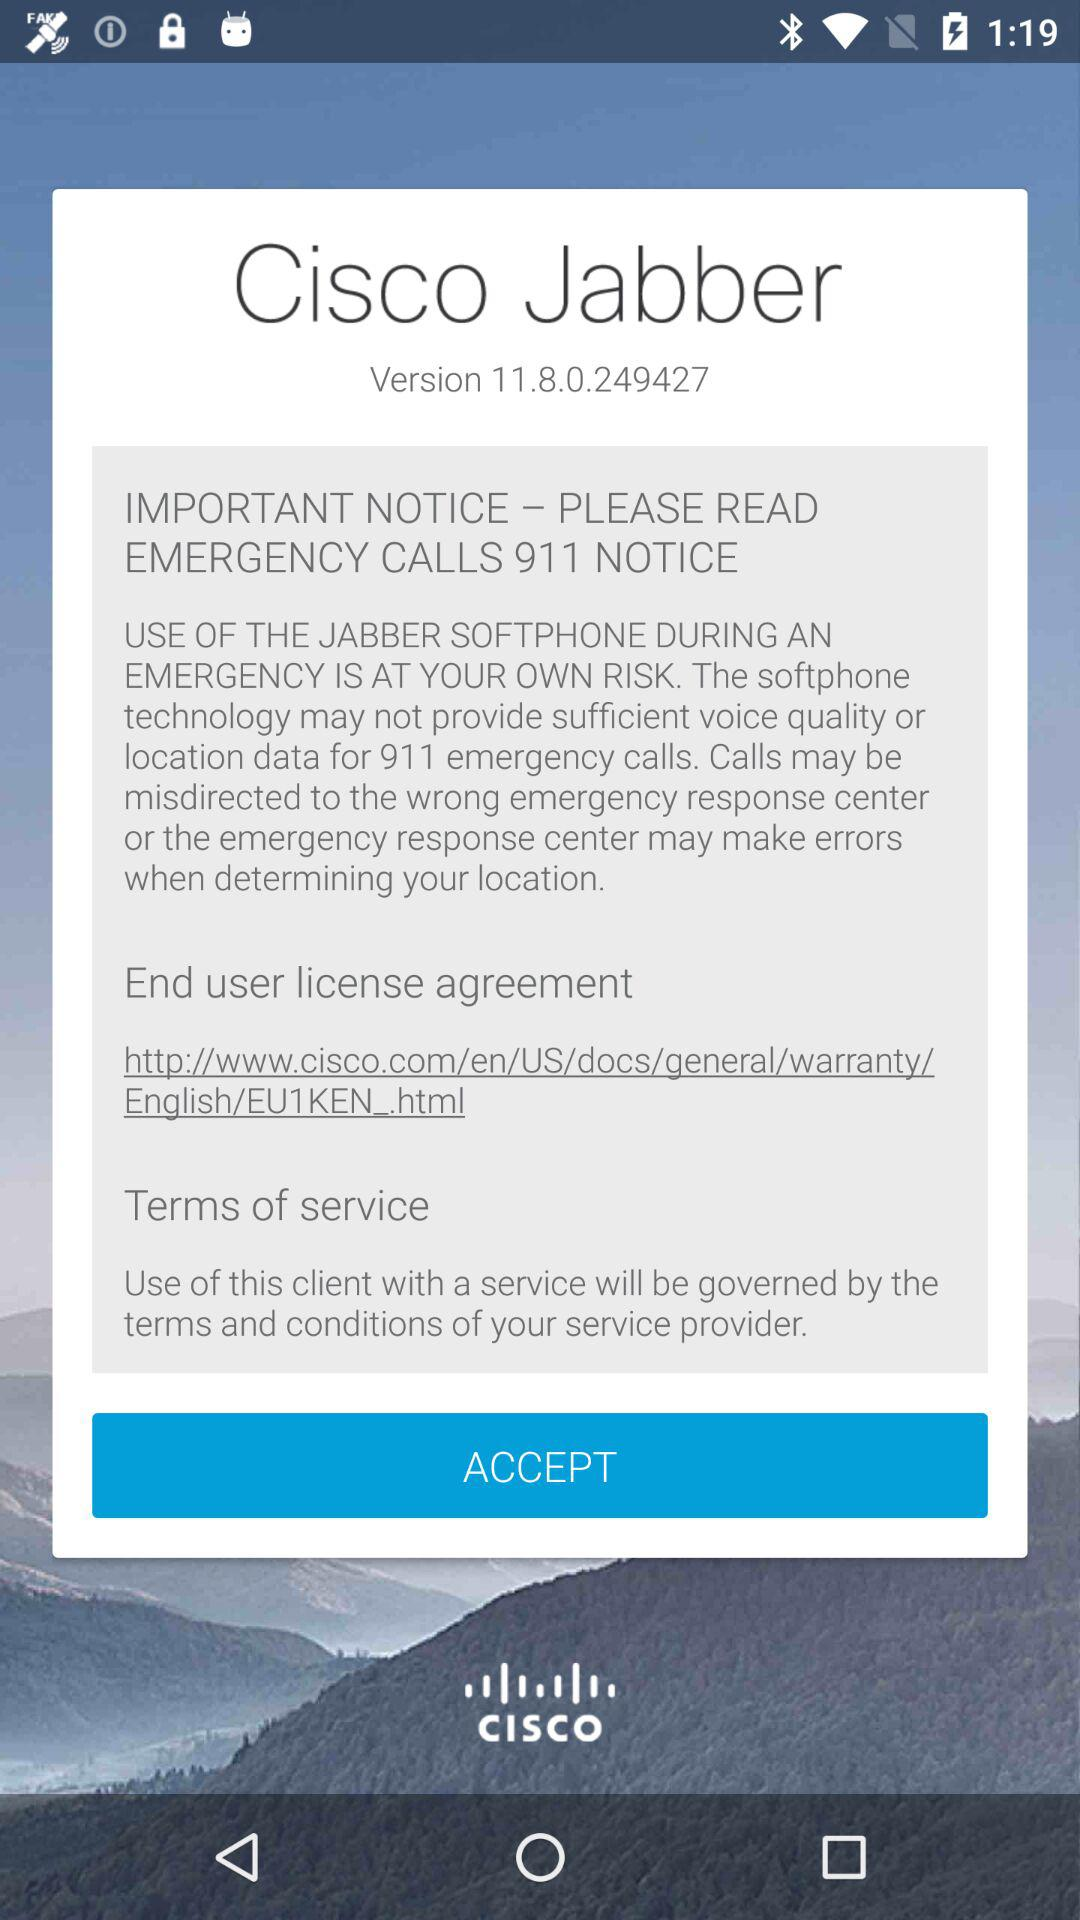What notice is important to read? The notice that is important to read is "EMERGENCY CALLS 911 NOTICE". 